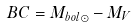Convert formula to latex. <formula><loc_0><loc_0><loc_500><loc_500>B C = M _ { b o l \odot } - M _ { V }</formula> 